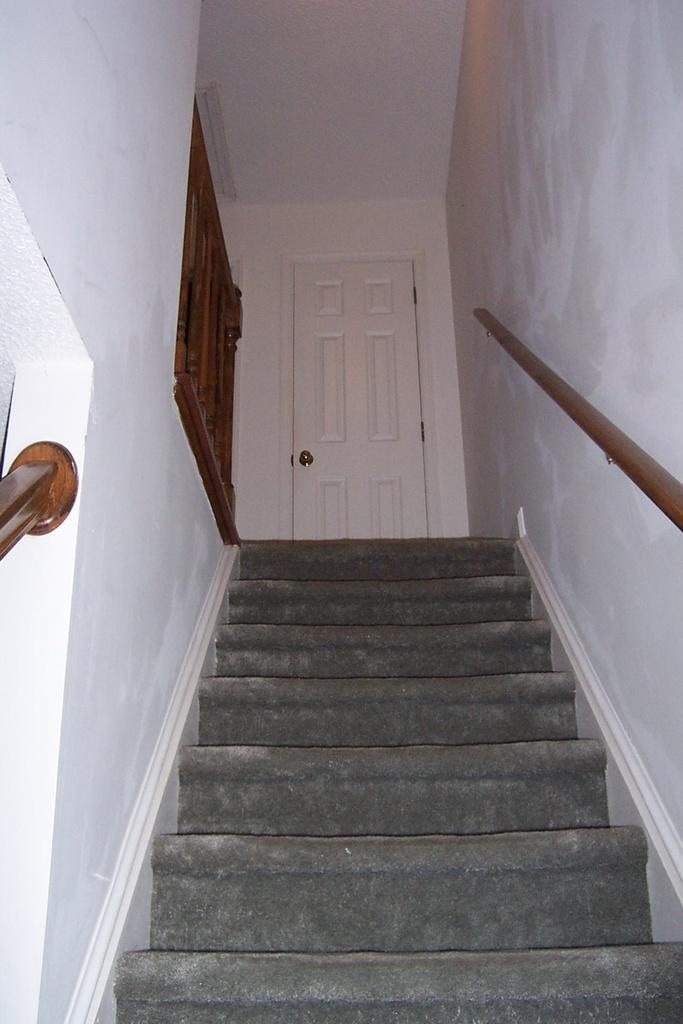How would you summarize this image in a sentence or two? In this image I can see a staircase and I can see a white color door visible in the middle and on the right side I can see a white color wall and on the left side I can see a white color wall. 